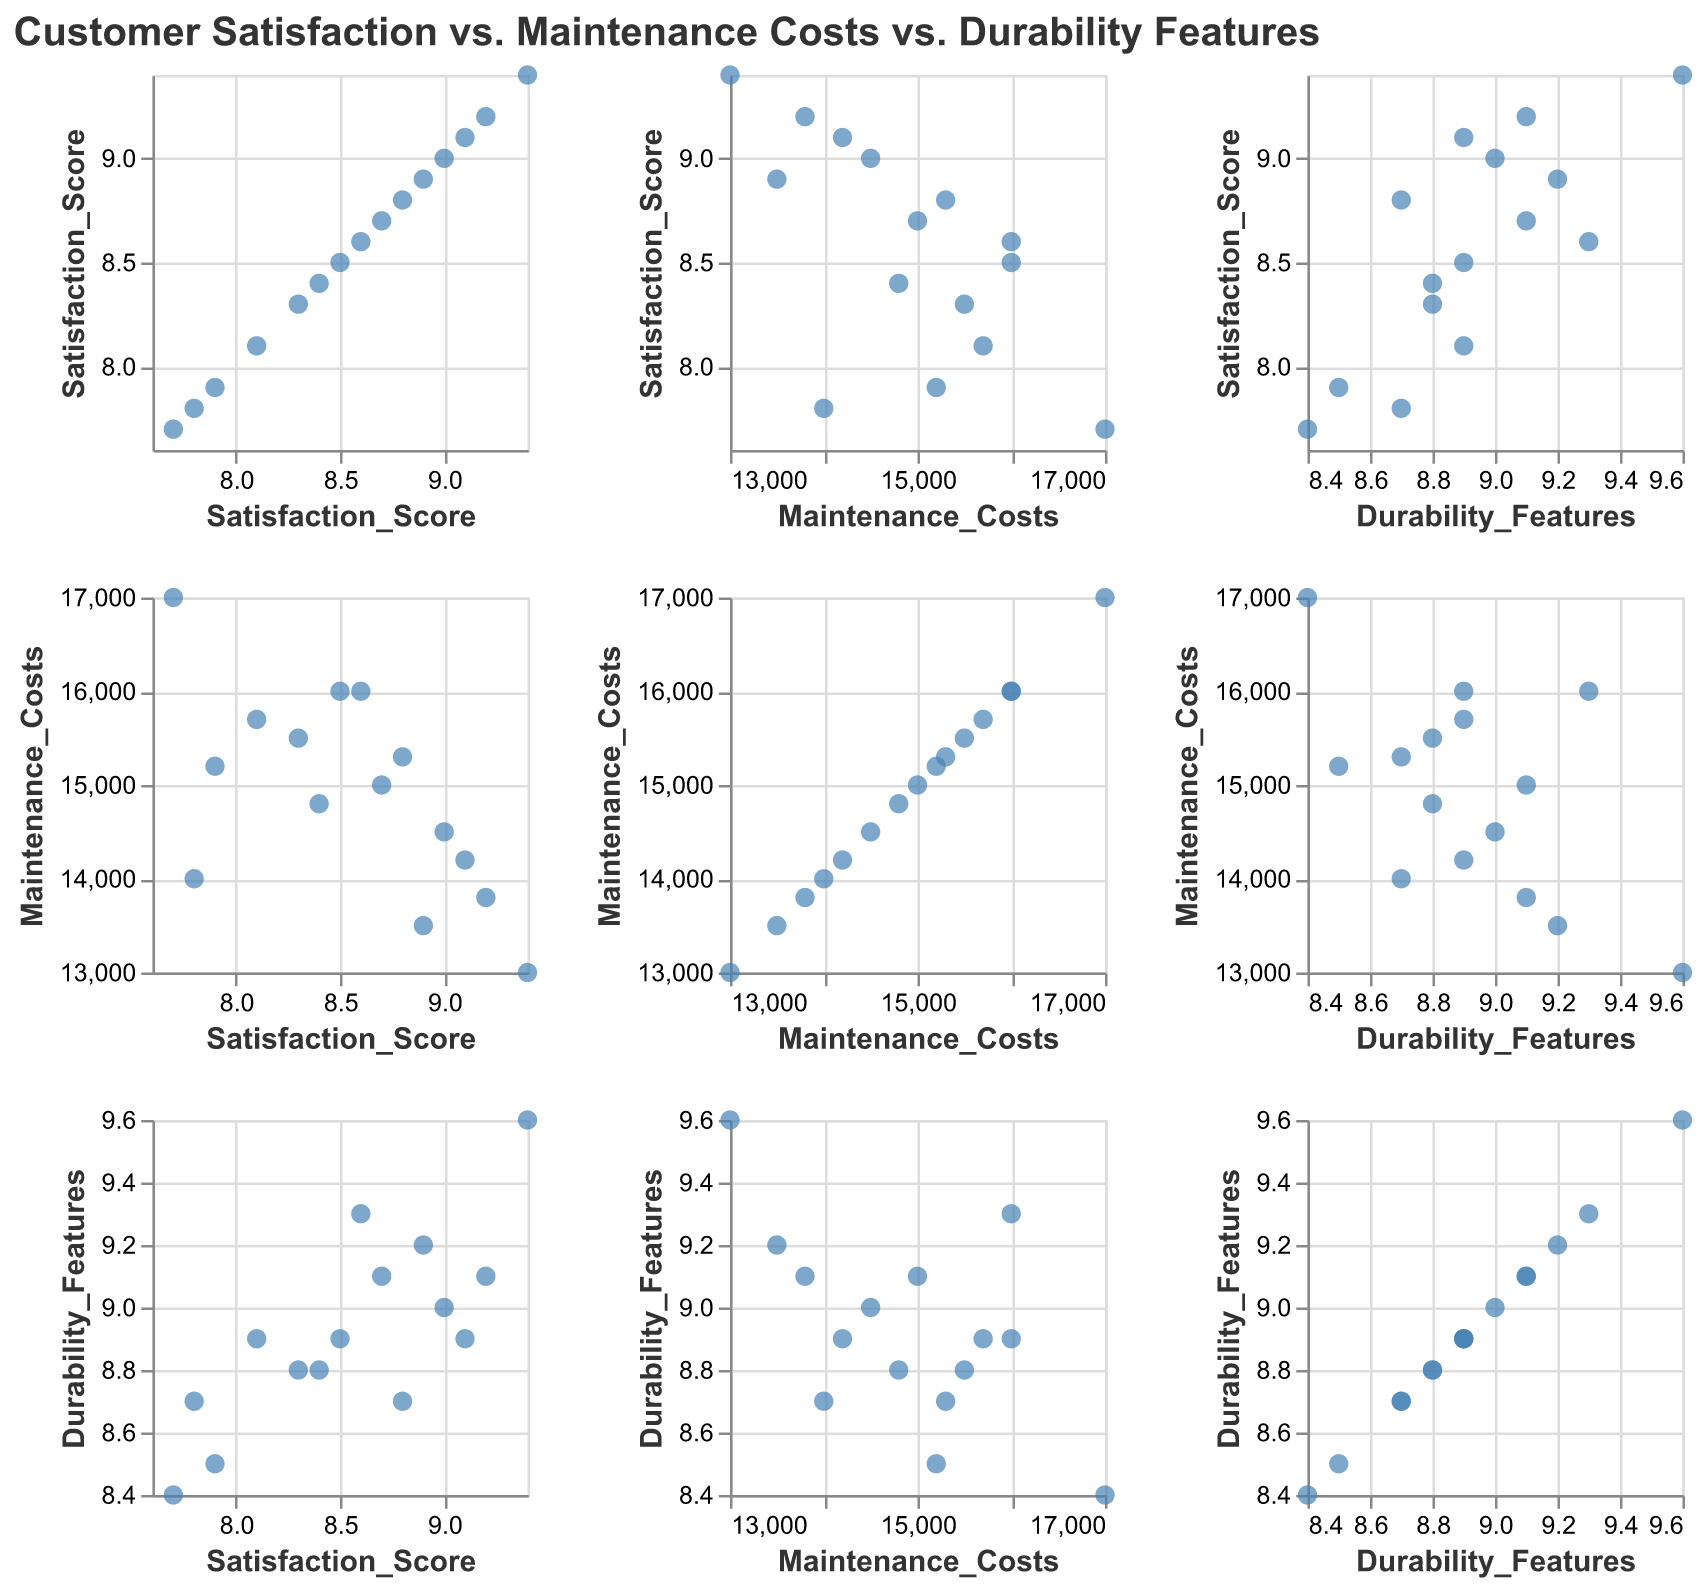What's the title of the figure? The title is displayed at the top of the figure in a bold font.
Answer: Customer Satisfaction vs. Maintenance Costs vs. Durability Features How many companies are included in this plot? By counting the data points or checking the tooltip information for each data point, one can identify there are 15 companies included.
Answer: 15 Which company has the highest satisfaction score? Observing the scatter plots corresponding to the Satisfaction Score axis and identifying the highest value, or by checking the tooltip of each data point, Tesla has the highest satisfaction score.
Answer: Tesla What is the relationship between Maintenance Costs and Durability Features? Looking at the scatter plot where Maintenance Costs is on one axis and Durability Features is on the other, there does not seem to be a strong visual correlation as the points are scattered.
Answer: No strong correlation Who has the lowest maintenance costs, and what is their satisfaction score? Identifying the lowest point on the Maintenance Costs axis and checking the tooltip information for that point reveals that Tesla has the lowest maintenance costs and a satisfaction score of 9.4.
Answer: Tesla, Satisfaction Score 9.4 Can you identify a company with a high durability but with relatively high maintenance costs? Checking the points with high values on the Durability Features axis and observing their Maintenance Costs reveals that Audi has high durability features (9.3) combined with high maintenance costs (16000).
Answer: Audi Which company shows a balance between all three metrics (Customer Satisfaction Score, Maintenance Costs, and Durability Features)? Looking at central or average values on each axis and identifying a point close to all three mid-values, BMW, with scores of 8.9 for satisfaction, 13500 for costs, and 9.2 for durability, stands out.
Answer: BMW What is the average durability feature score of the companies? Summing all the Durability Features scores (9.1, 9.6, 8.9, 8.7, 8.8, 9.0, 9.2, 8.9, 9.3, 8.5, 8.8, 8.4, 8.9, 9.1, 8.7) and dividing by 15 provides the average durability score, which is approximately 8.91.
Answer: 8.91 Is there any company with both a low satisfaction score and high maintenance costs? Identifying points low on the Satisfaction Score axis and high on the Maintenance Costs axis, Jaguar fits the criteria with a satisfaction score of 7.7 and maintenance costs of 17000.
Answer: Jaguar What is the spread of satisfaction scores among the companies? Looking at the range of values on the Satisfaction Score axis, the scores range from 7.7 to 9.4, indicating the spread.
Answer: 7.7 to 9.4 